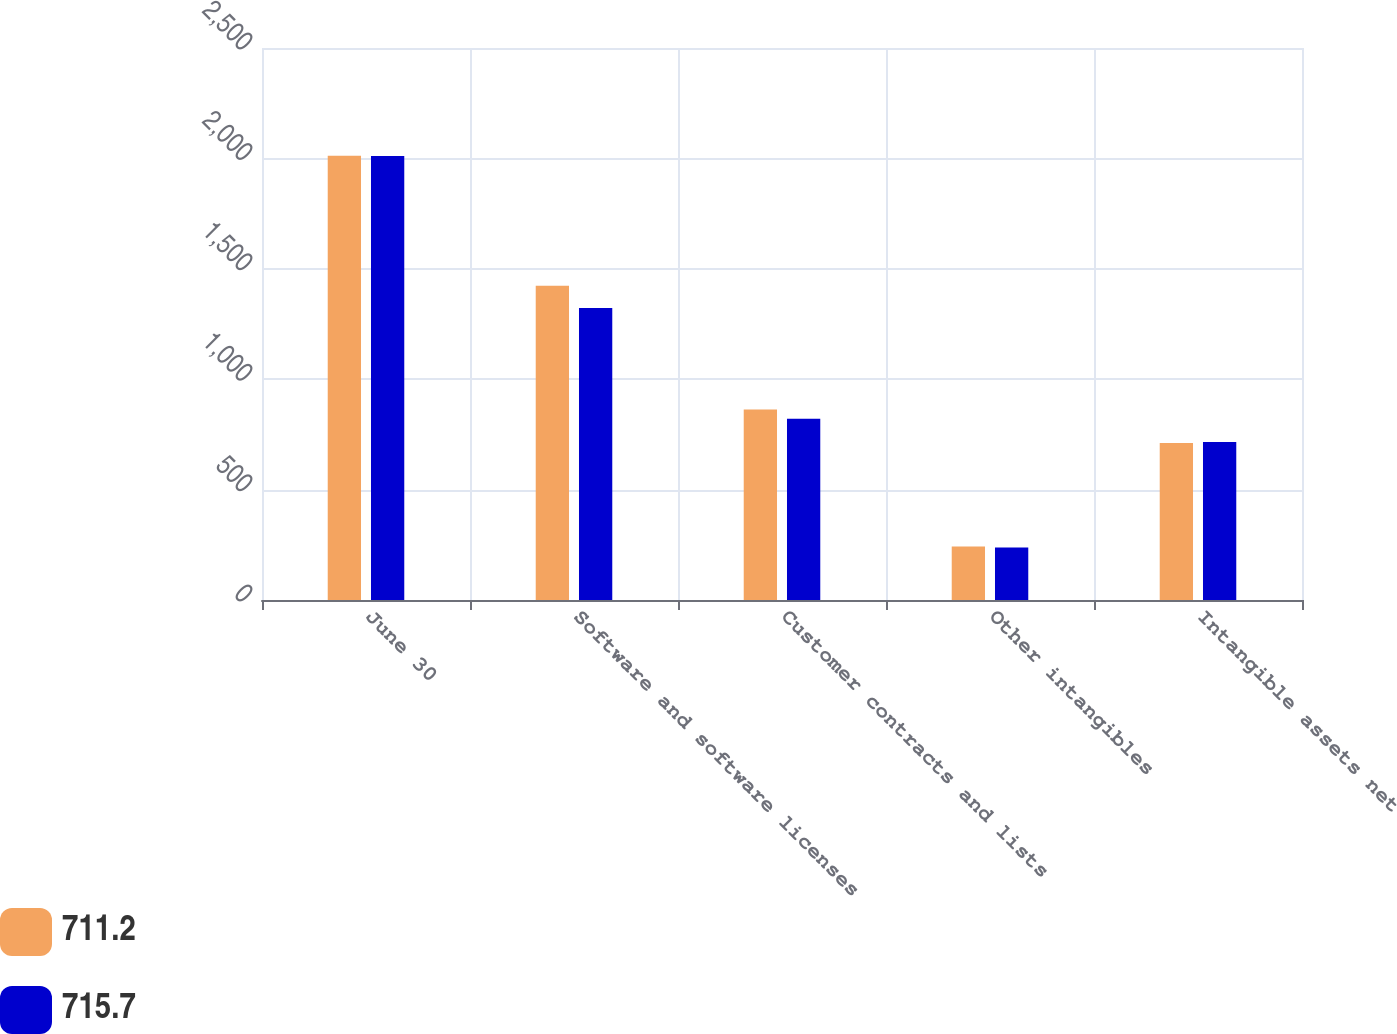Convert chart to OTSL. <chart><loc_0><loc_0><loc_500><loc_500><stacked_bar_chart><ecel><fcel>June 30<fcel>Software and software licenses<fcel>Customer contracts and lists<fcel>Other intangibles<fcel>Intangible assets net<nl><fcel>711.2<fcel>2012<fcel>1423.7<fcel>863.1<fcel>241.9<fcel>711.2<nl><fcel>715.7<fcel>2011<fcel>1322.4<fcel>821<fcel>238.3<fcel>715.7<nl></chart> 